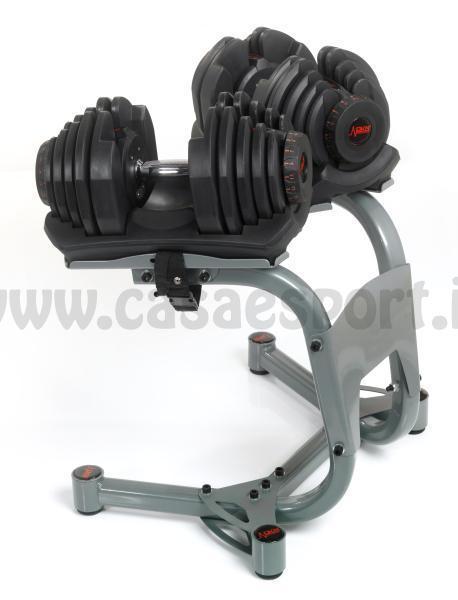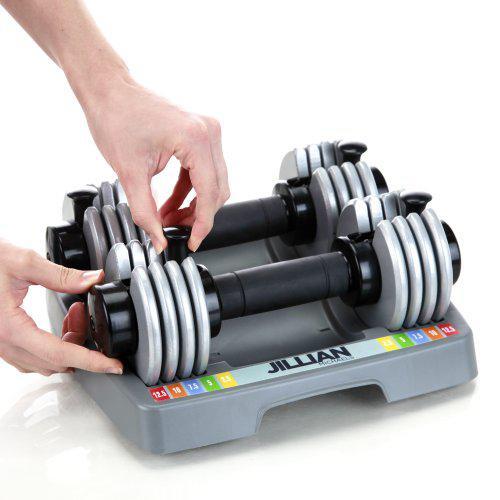The first image is the image on the left, the second image is the image on the right. Analyze the images presented: Is the assertion "A person is touching the dumbbells in the right image only." valid? Answer yes or no. Yes. The first image is the image on the left, the second image is the image on the right. Examine the images to the left and right. Is the description "A person is interacting with the weights in the image on the right." accurate? Answer yes or no. Yes. 